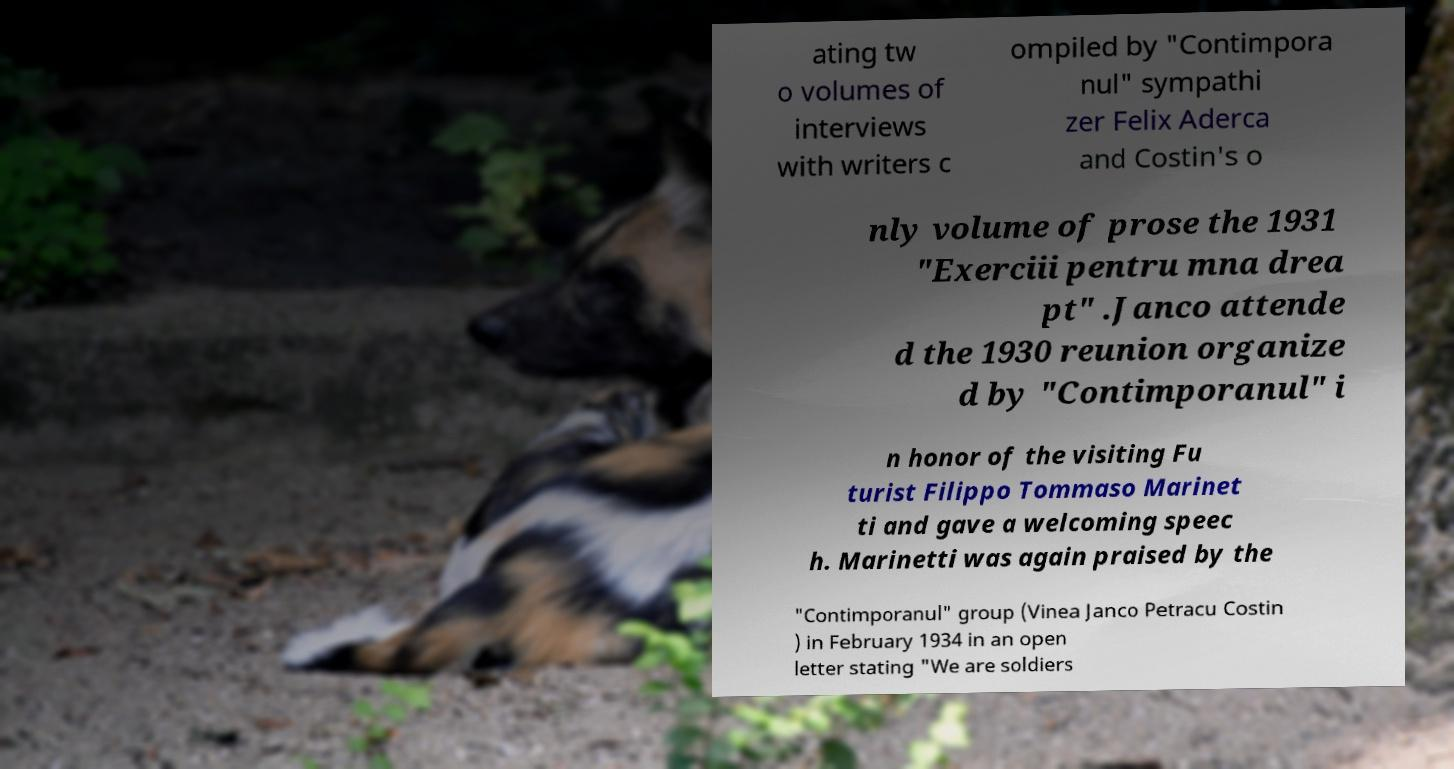Can you accurately transcribe the text from the provided image for me? ating tw o volumes of interviews with writers c ompiled by "Contimpora nul" sympathi zer Felix Aderca and Costin's o nly volume of prose the 1931 "Exerciii pentru mna drea pt" .Janco attende d the 1930 reunion organize d by "Contimporanul" i n honor of the visiting Fu turist Filippo Tommaso Marinet ti and gave a welcoming speec h. Marinetti was again praised by the "Contimporanul" group (Vinea Janco Petracu Costin ) in February 1934 in an open letter stating "We are soldiers 